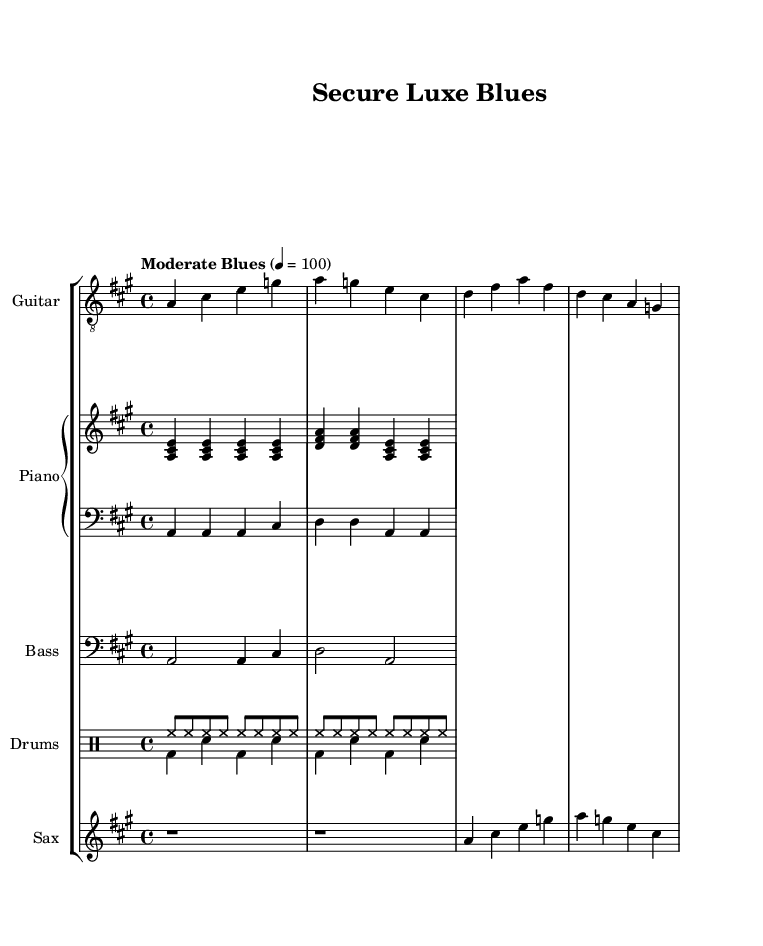What is the key signature of this music? The key signature is A major, which has three sharps (F#, C#, G#). This is indicated by the presence of these sharps at the beginning of the staff.
Answer: A major What is the time signature of the piece? The time signature is 4/4, which is reflected in the notation at the beginning of the music. This signifies that there are four beats in each measure.
Answer: 4/4 What is the tempo marking for this music? The tempo marking is "Moderate Blues," indicated in the score along with a metronome marking of 100 beats per minute. This suggests a laid-back and steady rhythm, typical of blues music.
Answer: Moderate Blues How many measures are there in the guitar part? The guitar part consists of four measures, as indicated by the grouping of notes within the measure lines. Each set of notes separated by vertical lines represents one measure.
Answer: Four Which instrument plays the bass line? The bass line is played by the instrument labeled "Bass," which is indicated in the score. The notes shown are typical bass notes that provide the foundational rhythm and harmonic support.
Answer: Bass What rhythmic pattern is used in the drum section? The drum section uses a combination of the hi-hat and bass drum patterns, typically being played in eighth notes for the hi-hat and a steady alternating pattern for the kick and snare. This combination is characteristic of blues music.
Answer: Alternating pattern What jazz element is present in this electric blues composition? The saxophone part adds a jazz element through improvisation and melodic embellishments that are typical in jazz music, complementing the blues structure. This fusion enhances the overall musical texture.
Answer: Saxophone 